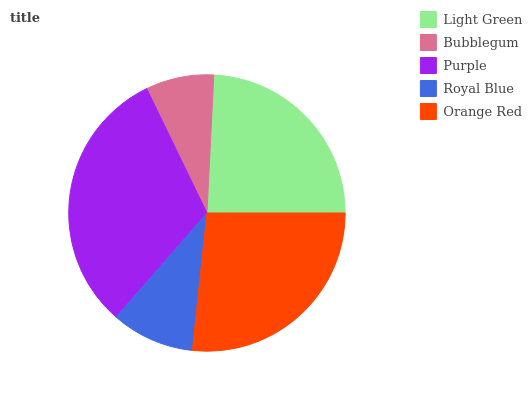Is Bubblegum the minimum?
Answer yes or no. Yes. Is Purple the maximum?
Answer yes or no. Yes. Is Purple the minimum?
Answer yes or no. No. Is Bubblegum the maximum?
Answer yes or no. No. Is Purple greater than Bubblegum?
Answer yes or no. Yes. Is Bubblegum less than Purple?
Answer yes or no. Yes. Is Bubblegum greater than Purple?
Answer yes or no. No. Is Purple less than Bubblegum?
Answer yes or no. No. Is Light Green the high median?
Answer yes or no. Yes. Is Light Green the low median?
Answer yes or no. Yes. Is Royal Blue the high median?
Answer yes or no. No. Is Purple the low median?
Answer yes or no. No. 